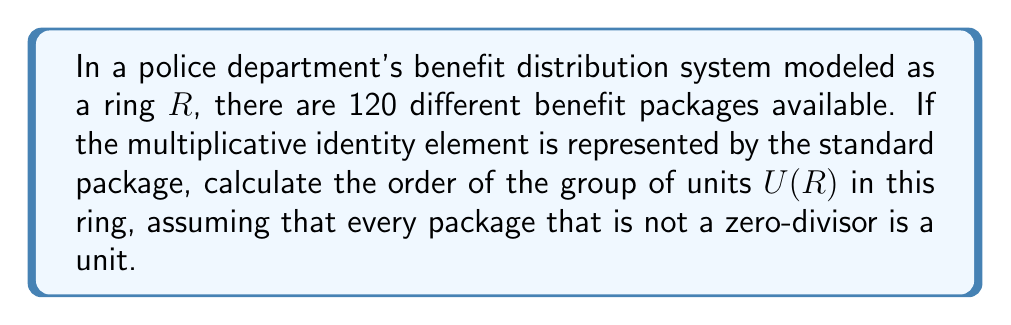Show me your answer to this math problem. To solve this problem, we need to follow these steps:

1) In a ring, the units are the elements that have multiplicative inverses. In this context, each benefit package that has an inverse (can be undone or reversed) is considered a unit.

2) We're told that every package that is not a zero-divisor is a unit. In ring theory, zero-divisors are elements $a \neq 0$ such that there exists a non-zero element $b$ where $ab = 0$.

3) In a finite ring, the number of zero-divisors plus the number of units plus 1 (for the zero element) equals the total number of elements in the ring.

4) Let $z$ be the number of zero-divisors, $u$ be the number of units, and $n$ be the total number of elements. Then:

   $z + u + 1 = n$

5) In this case, $n = 120$ (total number of benefit packages).

6) We're not given information about zero-divisors, but we can deduce that the zero element in this ring would represent the absence of a benefit package.

7) Therefore, the number of units is:

   $u = n - z - 1 = 120 - z - 1 = 119 - z$

8) The order of the group of units $U(R)$ is equal to the number of units.

9) While we don't know the exact value of $z$, we know that the order of $U(R)$ is at most 119 (when $z = 0$).

10) In ring theory, a common structure for finite rings is $\mathbb{Z}/n\mathbb{Z}$. If our ring follows this structure, then the number of units would be given by Euler's totient function $\phi(120)$.

11) $\phi(120) = \phi(2^3 \times 3 \times 5) = (2^3 - 2^2) \times (3-1) \times (5-1) = 4 \times 2 \times 4 = 32$

Therefore, the most likely order for $U(R)$ is 32, assuming the ring follows a structure similar to $\mathbb{Z}/120\mathbb{Z}$.
Answer: The order of the group of units $U(R)$ is most likely 32. 